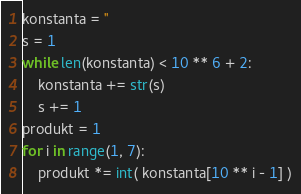<code> <loc_0><loc_0><loc_500><loc_500><_Python_>konstanta = ''
s = 1
while len(konstanta) < 10 ** 6 + 2:
    konstanta += str(s)
    s += 1
produkt = 1
for i in range(1, 7):
    produkt *= int( konstanta[10 ** i - 1] )</code> 